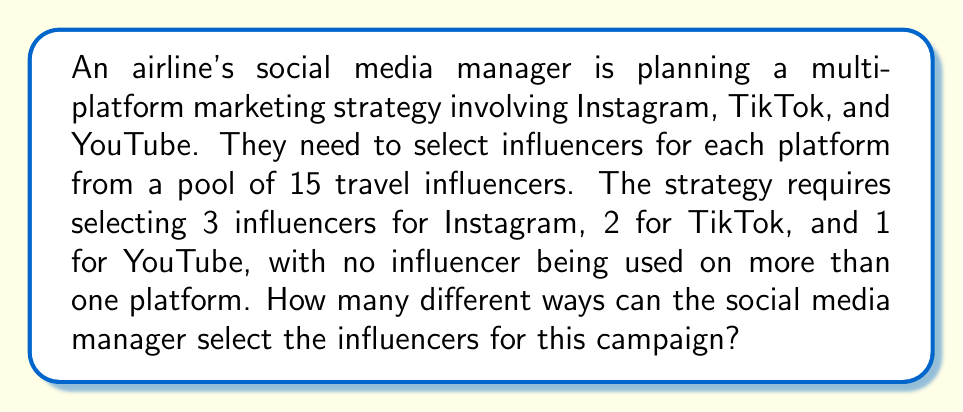Give your solution to this math problem. Let's approach this step-by-step using the multiplication principle and combinations:

1) First, we need to select 3 influencers for Instagram from the pool of 15.
   This can be done in $\binom{15}{3}$ ways.

2) After selecting for Instagram, we have 12 influencers left. From these, we need to select 2 for TikTok.
   This can be done in $\binom{12}{2}$ ways.

3) Finally, we need to select 1 influencer for YouTube from the remaining 10.
   This can be done in $\binom{10}{1}$ ways.

4) By the multiplication principle, the total number of ways to select the influencers is:

   $$\binom{15}{3} \times \binom{12}{2} \times \binom{10}{1}$$

5) Let's calculate each combination:

   $\binom{15}{3} = \frac{15!}{3!(15-3)!} = \frac{15!}{3!12!} = 455$

   $\binom{12}{2} = \frac{12!}{2!(12-2)!} = \frac{12!}{2!10!} = 66$

   $\binom{10}{1} = \frac{10!}{1!(10-1)!} = \frac{10!}{1!9!} = 10$

6) Now, we multiply these results:

   $455 \times 66 \times 10 = 300,300$

Therefore, there are 300,300 different ways to select the influencers for this campaign.
Answer: 300,300 